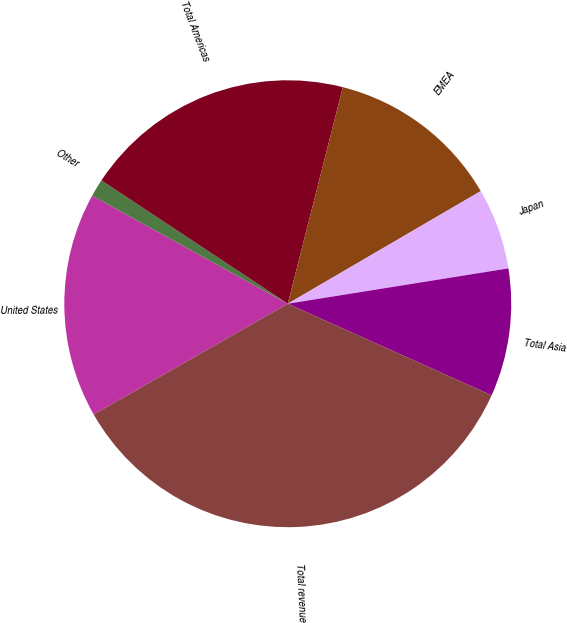<chart> <loc_0><loc_0><loc_500><loc_500><pie_chart><fcel>United States<fcel>Other<fcel>Total Americas<fcel>EMEA<fcel>Japan<fcel>Total Asia<fcel>Total revenue<nl><fcel>16.29%<fcel>1.27%<fcel>19.66%<fcel>12.63%<fcel>5.88%<fcel>9.25%<fcel>35.03%<nl></chart> 